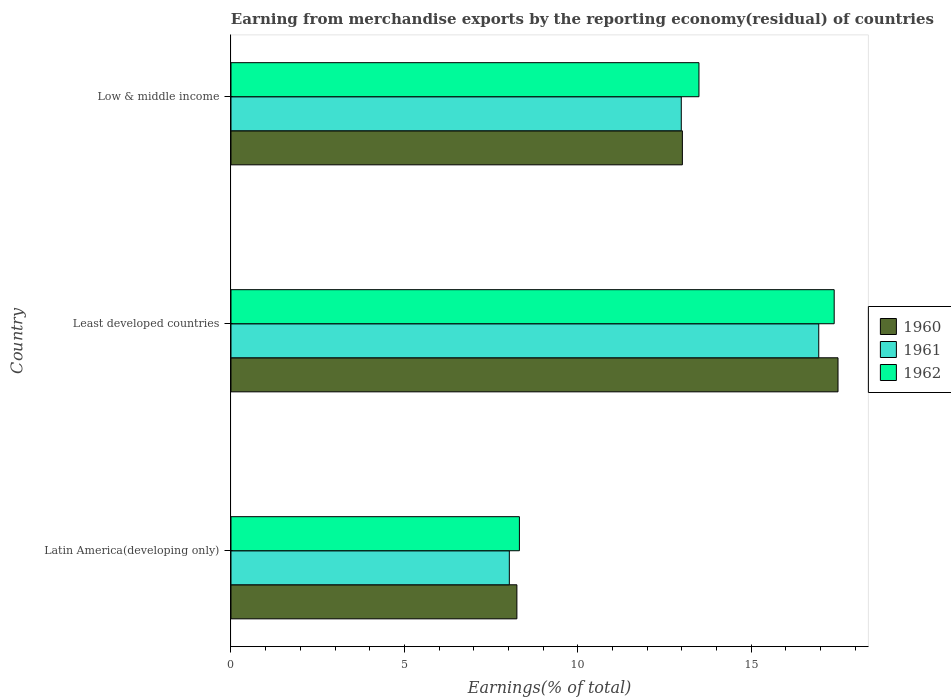Are the number of bars per tick equal to the number of legend labels?
Keep it short and to the point. Yes. How many bars are there on the 3rd tick from the top?
Your response must be concise. 3. What is the label of the 2nd group of bars from the top?
Your answer should be compact. Least developed countries. In how many cases, is the number of bars for a given country not equal to the number of legend labels?
Give a very brief answer. 0. What is the percentage of amount earned from merchandise exports in 1961 in Least developed countries?
Give a very brief answer. 16.95. Across all countries, what is the maximum percentage of amount earned from merchandise exports in 1960?
Keep it short and to the point. 17.5. Across all countries, what is the minimum percentage of amount earned from merchandise exports in 1962?
Offer a terse response. 8.32. In which country was the percentage of amount earned from merchandise exports in 1961 maximum?
Keep it short and to the point. Least developed countries. In which country was the percentage of amount earned from merchandise exports in 1961 minimum?
Provide a succinct answer. Latin America(developing only). What is the total percentage of amount earned from merchandise exports in 1961 in the graph?
Ensure brevity in your answer.  37.96. What is the difference between the percentage of amount earned from merchandise exports in 1961 in Least developed countries and that in Low & middle income?
Your response must be concise. 3.96. What is the difference between the percentage of amount earned from merchandise exports in 1962 in Latin America(developing only) and the percentage of amount earned from merchandise exports in 1960 in Least developed countries?
Provide a succinct answer. -9.19. What is the average percentage of amount earned from merchandise exports in 1960 per country?
Your answer should be very brief. 12.92. What is the difference between the percentage of amount earned from merchandise exports in 1962 and percentage of amount earned from merchandise exports in 1960 in Low & middle income?
Your answer should be very brief. 0.48. In how many countries, is the percentage of amount earned from merchandise exports in 1961 greater than 17 %?
Provide a short and direct response. 0. What is the ratio of the percentage of amount earned from merchandise exports in 1961 in Latin America(developing only) to that in Least developed countries?
Provide a short and direct response. 0.47. Is the difference between the percentage of amount earned from merchandise exports in 1962 in Least developed countries and Low & middle income greater than the difference between the percentage of amount earned from merchandise exports in 1960 in Least developed countries and Low & middle income?
Keep it short and to the point. No. What is the difference between the highest and the second highest percentage of amount earned from merchandise exports in 1961?
Provide a short and direct response. 3.96. What is the difference between the highest and the lowest percentage of amount earned from merchandise exports in 1962?
Your response must be concise. 9.08. In how many countries, is the percentage of amount earned from merchandise exports in 1961 greater than the average percentage of amount earned from merchandise exports in 1961 taken over all countries?
Keep it short and to the point. 2. Is the sum of the percentage of amount earned from merchandise exports in 1961 in Latin America(developing only) and Low & middle income greater than the maximum percentage of amount earned from merchandise exports in 1960 across all countries?
Your response must be concise. Yes. What does the 1st bar from the top in Low & middle income represents?
Your response must be concise. 1962. What does the 2nd bar from the bottom in Least developed countries represents?
Ensure brevity in your answer.  1961. Is it the case that in every country, the sum of the percentage of amount earned from merchandise exports in 1961 and percentage of amount earned from merchandise exports in 1960 is greater than the percentage of amount earned from merchandise exports in 1962?
Your answer should be very brief. Yes. How many bars are there?
Give a very brief answer. 9. Are all the bars in the graph horizontal?
Ensure brevity in your answer.  Yes. What is the difference between two consecutive major ticks on the X-axis?
Provide a succinct answer. 5. Are the values on the major ticks of X-axis written in scientific E-notation?
Give a very brief answer. No. Does the graph contain any zero values?
Keep it short and to the point. No. Does the graph contain grids?
Your response must be concise. No. How many legend labels are there?
Make the answer very short. 3. What is the title of the graph?
Your answer should be compact. Earning from merchandise exports by the reporting economy(residual) of countries. What is the label or title of the X-axis?
Keep it short and to the point. Earnings(% of total). What is the label or title of the Y-axis?
Offer a terse response. Country. What is the Earnings(% of total) in 1960 in Latin America(developing only)?
Provide a short and direct response. 8.24. What is the Earnings(% of total) in 1961 in Latin America(developing only)?
Offer a terse response. 8.03. What is the Earnings(% of total) of 1962 in Latin America(developing only)?
Keep it short and to the point. 8.32. What is the Earnings(% of total) of 1960 in Least developed countries?
Offer a very short reply. 17.5. What is the Earnings(% of total) of 1961 in Least developed countries?
Your response must be concise. 16.95. What is the Earnings(% of total) of 1962 in Least developed countries?
Offer a very short reply. 17.39. What is the Earnings(% of total) in 1960 in Low & middle income?
Keep it short and to the point. 13.02. What is the Earnings(% of total) of 1961 in Low & middle income?
Provide a short and direct response. 12.99. What is the Earnings(% of total) in 1962 in Low & middle income?
Provide a succinct answer. 13.49. Across all countries, what is the maximum Earnings(% of total) of 1960?
Give a very brief answer. 17.5. Across all countries, what is the maximum Earnings(% of total) of 1961?
Your response must be concise. 16.95. Across all countries, what is the maximum Earnings(% of total) in 1962?
Give a very brief answer. 17.39. Across all countries, what is the minimum Earnings(% of total) of 1960?
Your answer should be compact. 8.24. Across all countries, what is the minimum Earnings(% of total) of 1961?
Provide a succinct answer. 8.03. Across all countries, what is the minimum Earnings(% of total) of 1962?
Offer a very short reply. 8.32. What is the total Earnings(% of total) of 1960 in the graph?
Keep it short and to the point. 38.77. What is the total Earnings(% of total) in 1961 in the graph?
Give a very brief answer. 37.96. What is the total Earnings(% of total) of 1962 in the graph?
Keep it short and to the point. 39.21. What is the difference between the Earnings(% of total) of 1960 in Latin America(developing only) and that in Least developed countries?
Ensure brevity in your answer.  -9.26. What is the difference between the Earnings(% of total) of 1961 in Latin America(developing only) and that in Least developed countries?
Make the answer very short. -8.92. What is the difference between the Earnings(% of total) in 1962 in Latin America(developing only) and that in Least developed countries?
Ensure brevity in your answer.  -9.08. What is the difference between the Earnings(% of total) in 1960 in Latin America(developing only) and that in Low & middle income?
Give a very brief answer. -4.77. What is the difference between the Earnings(% of total) of 1961 in Latin America(developing only) and that in Low & middle income?
Your response must be concise. -4.96. What is the difference between the Earnings(% of total) in 1962 in Latin America(developing only) and that in Low & middle income?
Give a very brief answer. -5.18. What is the difference between the Earnings(% of total) in 1960 in Least developed countries and that in Low & middle income?
Your answer should be compact. 4.49. What is the difference between the Earnings(% of total) in 1961 in Least developed countries and that in Low & middle income?
Provide a short and direct response. 3.96. What is the difference between the Earnings(% of total) of 1962 in Least developed countries and that in Low & middle income?
Offer a very short reply. 3.9. What is the difference between the Earnings(% of total) of 1960 in Latin America(developing only) and the Earnings(% of total) of 1961 in Least developed countries?
Your response must be concise. -8.7. What is the difference between the Earnings(% of total) of 1960 in Latin America(developing only) and the Earnings(% of total) of 1962 in Least developed countries?
Offer a very short reply. -9.15. What is the difference between the Earnings(% of total) of 1961 in Latin America(developing only) and the Earnings(% of total) of 1962 in Least developed countries?
Keep it short and to the point. -9.37. What is the difference between the Earnings(% of total) in 1960 in Latin America(developing only) and the Earnings(% of total) in 1961 in Low & middle income?
Your answer should be compact. -4.74. What is the difference between the Earnings(% of total) of 1960 in Latin America(developing only) and the Earnings(% of total) of 1962 in Low & middle income?
Ensure brevity in your answer.  -5.25. What is the difference between the Earnings(% of total) of 1961 in Latin America(developing only) and the Earnings(% of total) of 1962 in Low & middle income?
Your answer should be very brief. -5.47. What is the difference between the Earnings(% of total) of 1960 in Least developed countries and the Earnings(% of total) of 1961 in Low & middle income?
Offer a terse response. 4.52. What is the difference between the Earnings(% of total) of 1960 in Least developed countries and the Earnings(% of total) of 1962 in Low & middle income?
Offer a very short reply. 4.01. What is the difference between the Earnings(% of total) of 1961 in Least developed countries and the Earnings(% of total) of 1962 in Low & middle income?
Make the answer very short. 3.45. What is the average Earnings(% of total) of 1960 per country?
Ensure brevity in your answer.  12.92. What is the average Earnings(% of total) of 1961 per country?
Offer a terse response. 12.65. What is the average Earnings(% of total) in 1962 per country?
Offer a very short reply. 13.07. What is the difference between the Earnings(% of total) in 1960 and Earnings(% of total) in 1961 in Latin America(developing only)?
Ensure brevity in your answer.  0.22. What is the difference between the Earnings(% of total) of 1960 and Earnings(% of total) of 1962 in Latin America(developing only)?
Keep it short and to the point. -0.07. What is the difference between the Earnings(% of total) in 1961 and Earnings(% of total) in 1962 in Latin America(developing only)?
Provide a succinct answer. -0.29. What is the difference between the Earnings(% of total) in 1960 and Earnings(% of total) in 1961 in Least developed countries?
Offer a very short reply. 0.56. What is the difference between the Earnings(% of total) in 1960 and Earnings(% of total) in 1962 in Least developed countries?
Offer a terse response. 0.11. What is the difference between the Earnings(% of total) of 1961 and Earnings(% of total) of 1962 in Least developed countries?
Offer a terse response. -0.45. What is the difference between the Earnings(% of total) in 1960 and Earnings(% of total) in 1961 in Low & middle income?
Your response must be concise. 0.03. What is the difference between the Earnings(% of total) of 1960 and Earnings(% of total) of 1962 in Low & middle income?
Ensure brevity in your answer.  -0.48. What is the difference between the Earnings(% of total) of 1961 and Earnings(% of total) of 1962 in Low & middle income?
Your answer should be very brief. -0.51. What is the ratio of the Earnings(% of total) of 1960 in Latin America(developing only) to that in Least developed countries?
Your answer should be compact. 0.47. What is the ratio of the Earnings(% of total) of 1961 in Latin America(developing only) to that in Least developed countries?
Make the answer very short. 0.47. What is the ratio of the Earnings(% of total) in 1962 in Latin America(developing only) to that in Least developed countries?
Ensure brevity in your answer.  0.48. What is the ratio of the Earnings(% of total) in 1960 in Latin America(developing only) to that in Low & middle income?
Provide a succinct answer. 0.63. What is the ratio of the Earnings(% of total) in 1961 in Latin America(developing only) to that in Low & middle income?
Keep it short and to the point. 0.62. What is the ratio of the Earnings(% of total) in 1962 in Latin America(developing only) to that in Low & middle income?
Provide a short and direct response. 0.62. What is the ratio of the Earnings(% of total) in 1960 in Least developed countries to that in Low & middle income?
Offer a very short reply. 1.34. What is the ratio of the Earnings(% of total) in 1961 in Least developed countries to that in Low & middle income?
Provide a short and direct response. 1.31. What is the ratio of the Earnings(% of total) in 1962 in Least developed countries to that in Low & middle income?
Provide a succinct answer. 1.29. What is the difference between the highest and the second highest Earnings(% of total) in 1960?
Provide a short and direct response. 4.49. What is the difference between the highest and the second highest Earnings(% of total) in 1961?
Give a very brief answer. 3.96. What is the difference between the highest and the second highest Earnings(% of total) in 1962?
Make the answer very short. 3.9. What is the difference between the highest and the lowest Earnings(% of total) in 1960?
Your answer should be compact. 9.26. What is the difference between the highest and the lowest Earnings(% of total) in 1961?
Keep it short and to the point. 8.92. What is the difference between the highest and the lowest Earnings(% of total) of 1962?
Keep it short and to the point. 9.08. 